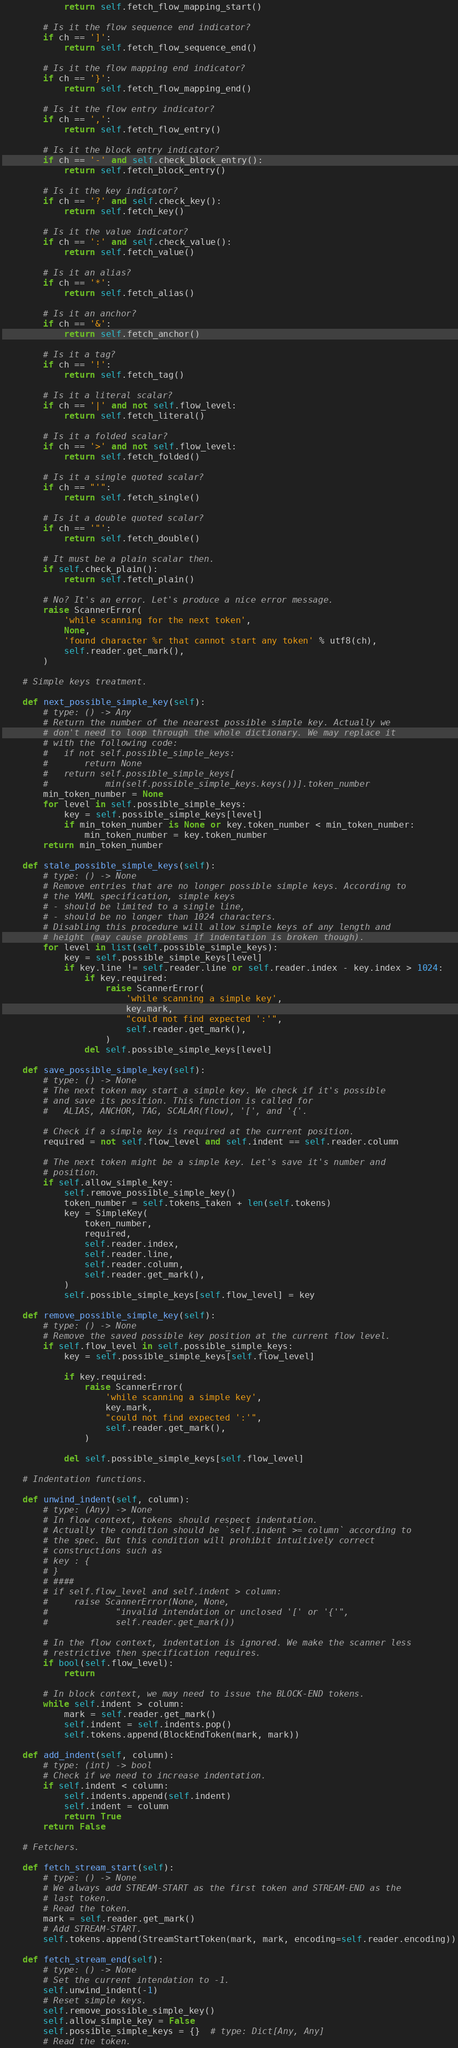<code> <loc_0><loc_0><loc_500><loc_500><_Python_>            return self.fetch_flow_mapping_start()

        # Is it the flow sequence end indicator?
        if ch == ']':
            return self.fetch_flow_sequence_end()

        # Is it the flow mapping end indicator?
        if ch == '}':
            return self.fetch_flow_mapping_end()

        # Is it the flow entry indicator?
        if ch == ',':
            return self.fetch_flow_entry()

        # Is it the block entry indicator?
        if ch == '-' and self.check_block_entry():
            return self.fetch_block_entry()

        # Is it the key indicator?
        if ch == '?' and self.check_key():
            return self.fetch_key()

        # Is it the value indicator?
        if ch == ':' and self.check_value():
            return self.fetch_value()

        # Is it an alias?
        if ch == '*':
            return self.fetch_alias()

        # Is it an anchor?
        if ch == '&':
            return self.fetch_anchor()

        # Is it a tag?
        if ch == '!':
            return self.fetch_tag()

        # Is it a literal scalar?
        if ch == '|' and not self.flow_level:
            return self.fetch_literal()

        # Is it a folded scalar?
        if ch == '>' and not self.flow_level:
            return self.fetch_folded()

        # Is it a single quoted scalar?
        if ch == "'":
            return self.fetch_single()

        # Is it a double quoted scalar?
        if ch == '"':
            return self.fetch_double()

        # It must be a plain scalar then.
        if self.check_plain():
            return self.fetch_plain()

        # No? It's an error. Let's produce a nice error message.
        raise ScannerError(
            'while scanning for the next token',
            None,
            'found character %r that cannot start any token' % utf8(ch),
            self.reader.get_mark(),
        )

    # Simple keys treatment.

    def next_possible_simple_key(self):
        # type: () -> Any
        # Return the number of the nearest possible simple key. Actually we
        # don't need to loop through the whole dictionary. We may replace it
        # with the following code:
        #   if not self.possible_simple_keys:
        #       return None
        #   return self.possible_simple_keys[
        #           min(self.possible_simple_keys.keys())].token_number
        min_token_number = None
        for level in self.possible_simple_keys:
            key = self.possible_simple_keys[level]
            if min_token_number is None or key.token_number < min_token_number:
                min_token_number = key.token_number
        return min_token_number

    def stale_possible_simple_keys(self):
        # type: () -> None
        # Remove entries that are no longer possible simple keys. According to
        # the YAML specification, simple keys
        # - should be limited to a single line,
        # - should be no longer than 1024 characters.
        # Disabling this procedure will allow simple keys of any length and
        # height (may cause problems if indentation is broken though).
        for level in list(self.possible_simple_keys):
            key = self.possible_simple_keys[level]
            if key.line != self.reader.line or self.reader.index - key.index > 1024:
                if key.required:
                    raise ScannerError(
                        'while scanning a simple key',
                        key.mark,
                        "could not find expected ':'",
                        self.reader.get_mark(),
                    )
                del self.possible_simple_keys[level]

    def save_possible_simple_key(self):
        # type: () -> None
        # The next token may start a simple key. We check if it's possible
        # and save its position. This function is called for
        #   ALIAS, ANCHOR, TAG, SCALAR(flow), '[', and '{'.

        # Check if a simple key is required at the current position.
        required = not self.flow_level and self.indent == self.reader.column

        # The next token might be a simple key. Let's save it's number and
        # position.
        if self.allow_simple_key:
            self.remove_possible_simple_key()
            token_number = self.tokens_taken + len(self.tokens)
            key = SimpleKey(
                token_number,
                required,
                self.reader.index,
                self.reader.line,
                self.reader.column,
                self.reader.get_mark(),
            )
            self.possible_simple_keys[self.flow_level] = key

    def remove_possible_simple_key(self):
        # type: () -> None
        # Remove the saved possible key position at the current flow level.
        if self.flow_level in self.possible_simple_keys:
            key = self.possible_simple_keys[self.flow_level]

            if key.required:
                raise ScannerError(
                    'while scanning a simple key',
                    key.mark,
                    "could not find expected ':'",
                    self.reader.get_mark(),
                )

            del self.possible_simple_keys[self.flow_level]

    # Indentation functions.

    def unwind_indent(self, column):
        # type: (Any) -> None
        # In flow context, tokens should respect indentation.
        # Actually the condition should be `self.indent >= column` according to
        # the spec. But this condition will prohibit intuitively correct
        # constructions such as
        # key : {
        # }
        # ####
        # if self.flow_level and self.indent > column:
        #     raise ScannerError(None, None,
        #             "invalid intendation or unclosed '[' or '{'",
        #             self.reader.get_mark())

        # In the flow context, indentation is ignored. We make the scanner less
        # restrictive then specification requires.
        if bool(self.flow_level):
            return

        # In block context, we may need to issue the BLOCK-END tokens.
        while self.indent > column:
            mark = self.reader.get_mark()
            self.indent = self.indents.pop()
            self.tokens.append(BlockEndToken(mark, mark))

    def add_indent(self, column):
        # type: (int) -> bool
        # Check if we need to increase indentation.
        if self.indent < column:
            self.indents.append(self.indent)
            self.indent = column
            return True
        return False

    # Fetchers.

    def fetch_stream_start(self):
        # type: () -> None
        # We always add STREAM-START as the first token and STREAM-END as the
        # last token.
        # Read the token.
        mark = self.reader.get_mark()
        # Add STREAM-START.
        self.tokens.append(StreamStartToken(mark, mark, encoding=self.reader.encoding))

    def fetch_stream_end(self):
        # type: () -> None
        # Set the current intendation to -1.
        self.unwind_indent(-1)
        # Reset simple keys.
        self.remove_possible_simple_key()
        self.allow_simple_key = False
        self.possible_simple_keys = {}  # type: Dict[Any, Any]
        # Read the token.</code> 